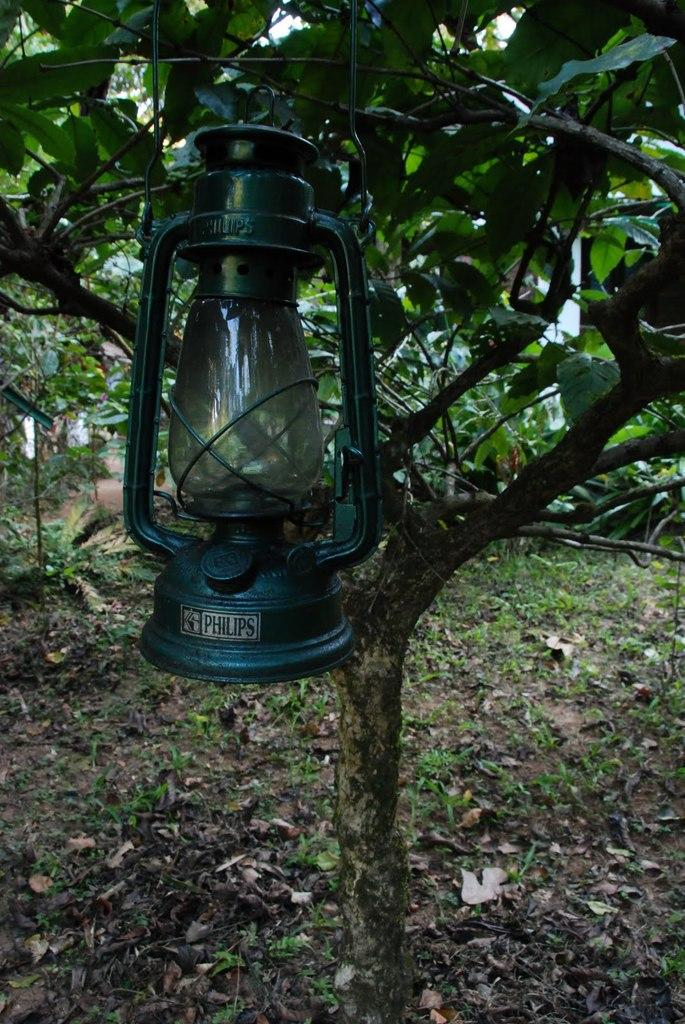What object can be seen in the image that provides light? There is a lantern in the image. What type of natural elements are present in the image? There are trees in the image. What type of bird can be seen perched on the lantern in the image? There is no bird, specifically a wren, present in the image. 